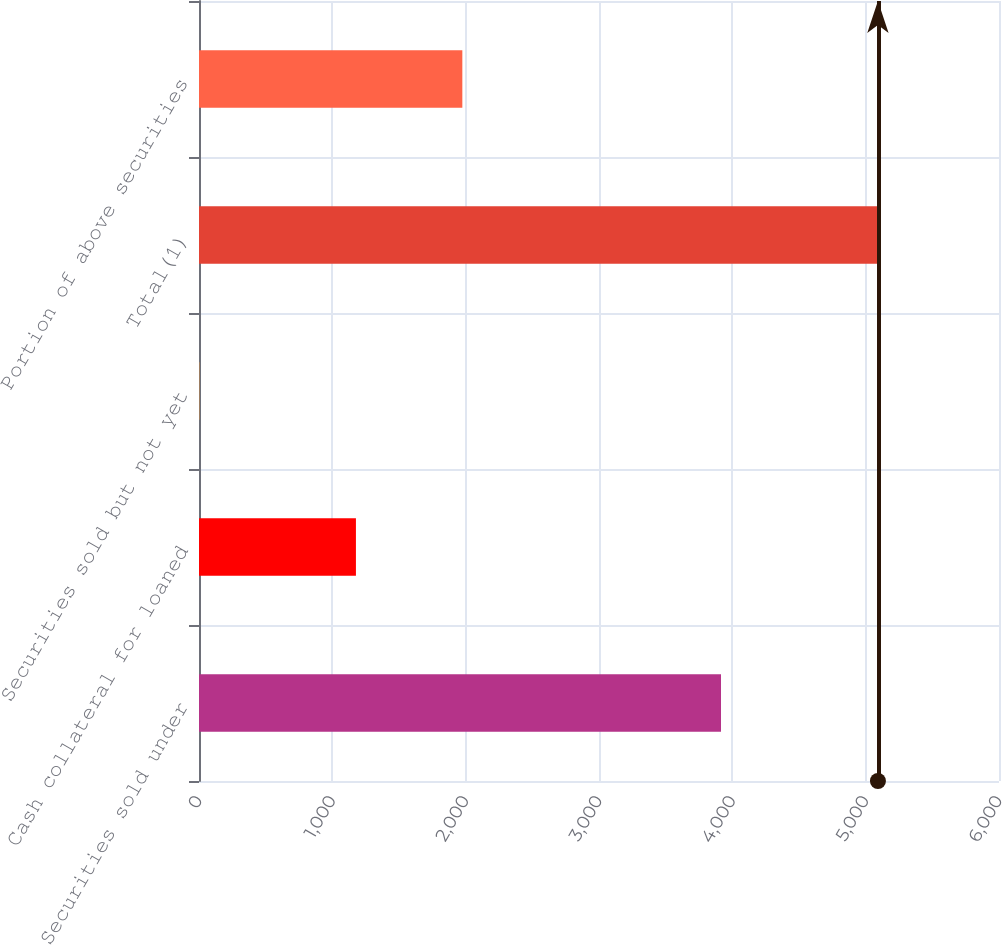Convert chart. <chart><loc_0><loc_0><loc_500><loc_500><bar_chart><fcel>Securities sold under<fcel>Cash collateral for loaned<fcel>Securities sold but not yet<fcel>Total(1)<fcel>Portion of above securities<nl><fcel>3915<fcel>1177<fcel>2.39<fcel>5092<fcel>1975<nl></chart> 